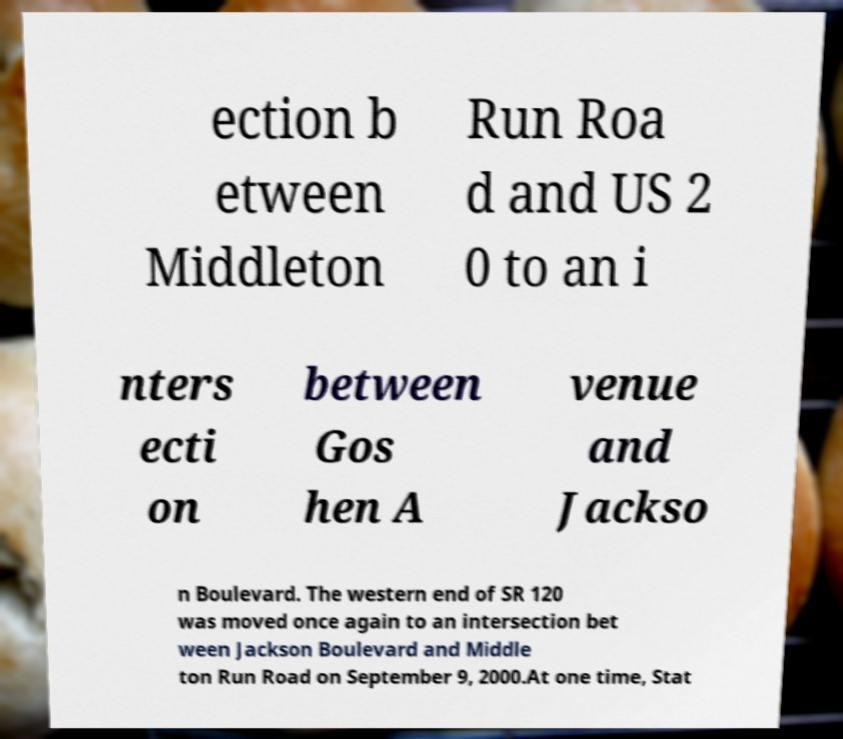Can you accurately transcribe the text from the provided image for me? ection b etween Middleton Run Roa d and US 2 0 to an i nters ecti on between Gos hen A venue and Jackso n Boulevard. The western end of SR 120 was moved once again to an intersection bet ween Jackson Boulevard and Middle ton Run Road on September 9, 2000.At one time, Stat 